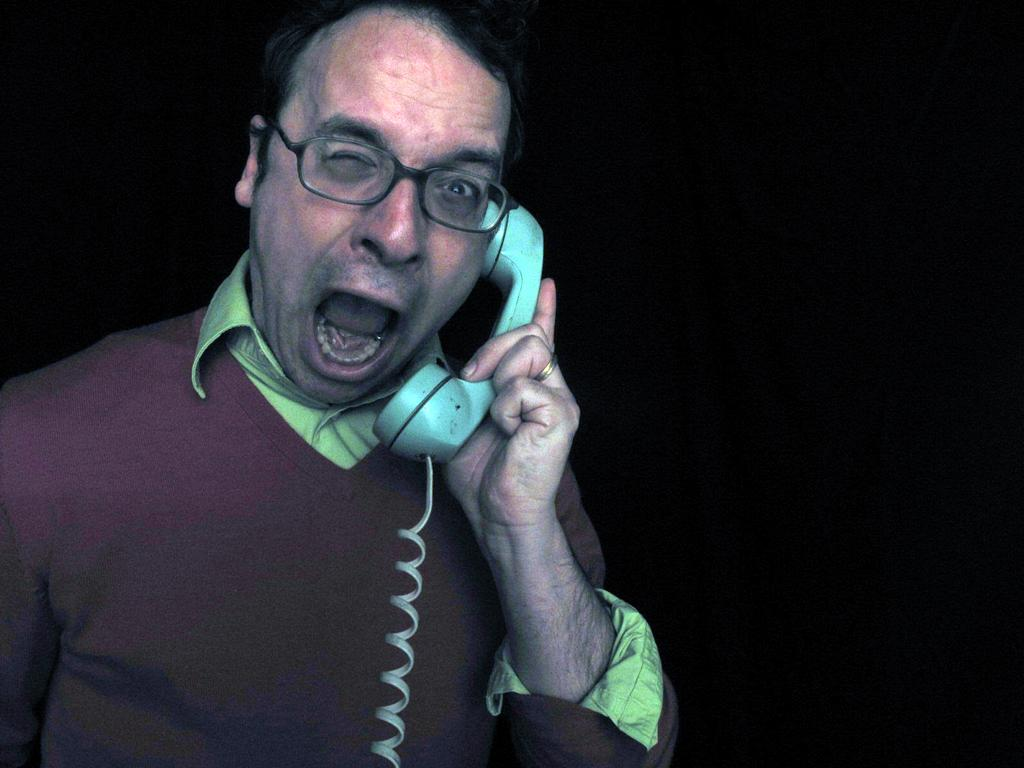What is the main subject of the image? There is a person in the image. What is the person holding in the image? The person is holding a telephone. Can you describe any accessories the person is wearing? The person is wearing spectacles. What is the color of the background in the image? The background of the image is black in color. What type of powder can be seen being used for destruction in the image? There is no powder or destruction present in the image; it features a person holding a telephone with a black background. Can you identify any wrens in the image? There are no wrens present in the image. 